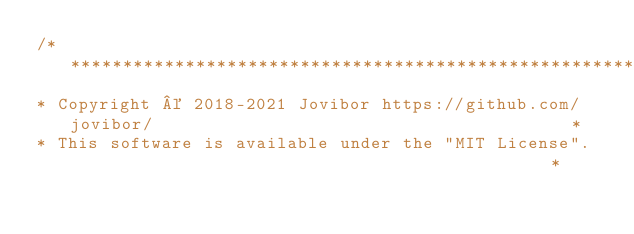<code> <loc_0><loc_0><loc_500><loc_500><_C_>/****************************************************************************************************
* Copyright © 2018-2021 Jovibor https://github.com/jovibor/   										*
* This software is available under the "MIT License".                                               *</code> 